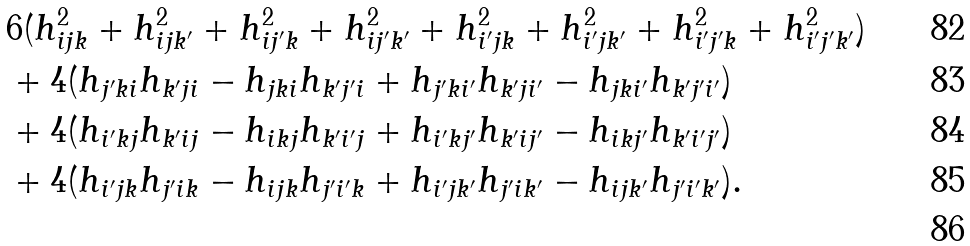Convert formula to latex. <formula><loc_0><loc_0><loc_500><loc_500>& 6 ( h _ { i j k } ^ { 2 } + h _ { i j k ^ { \prime } } ^ { 2 } + h _ { i j ^ { \prime } k } ^ { 2 } + h _ { i j ^ { \prime } k ^ { \prime } } ^ { 2 } + h _ { i ^ { \prime } j k } ^ { 2 } + h _ { i ^ { \prime } j k ^ { \prime } } ^ { 2 } + h _ { i ^ { \prime } j ^ { \prime } k } ^ { 2 } + h _ { i ^ { \prime } j ^ { \prime } k ^ { \prime } } ^ { 2 } ) \\ & + 4 ( h _ { j ^ { \prime } k i } h _ { k ^ { \prime } j i } - h _ { j k i } h _ { k ^ { \prime } j ^ { \prime } i } + h _ { j ^ { \prime } k i ^ { \prime } } h _ { k ^ { \prime } j i ^ { \prime } } - h _ { j k i ^ { \prime } } h _ { k ^ { \prime } j ^ { \prime } i ^ { \prime } } ) \\ & + 4 ( h _ { i ^ { \prime } k j } h _ { k ^ { \prime } i j } - h _ { i k j } h _ { k ^ { \prime } i ^ { \prime } j } + h _ { i ^ { \prime } k j ^ { \prime } } h _ { k ^ { \prime } i j ^ { \prime } } - h _ { i k j ^ { \prime } } h _ { k ^ { \prime } i ^ { \prime } j ^ { \prime } } ) \\ & + 4 ( h _ { i ^ { \prime } j k } h _ { j ^ { \prime } i k } - h _ { i j k } h _ { j ^ { \prime } i ^ { \prime } k } + h _ { i ^ { \prime } j k ^ { \prime } } h _ { j ^ { \prime } i k ^ { \prime } } - h _ { i j k ^ { \prime } } h _ { j ^ { \prime } i ^ { \prime } k ^ { \prime } } ) . \\</formula> 